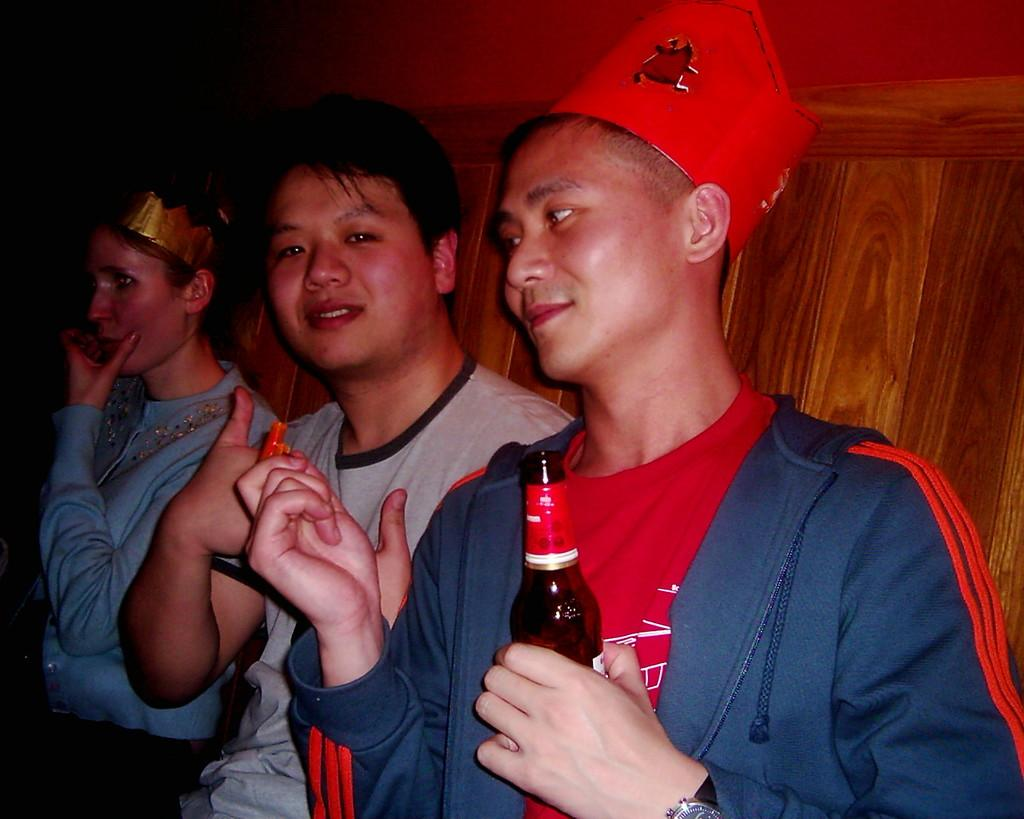How many people are in the image? There are people in the image. What is one of the people holding in their hands? One of the people is holding a beverage bottle in their hands. What type of net is being used to prevent the loss of seeds in the image? There is no net, loss, or seed present in the image. 